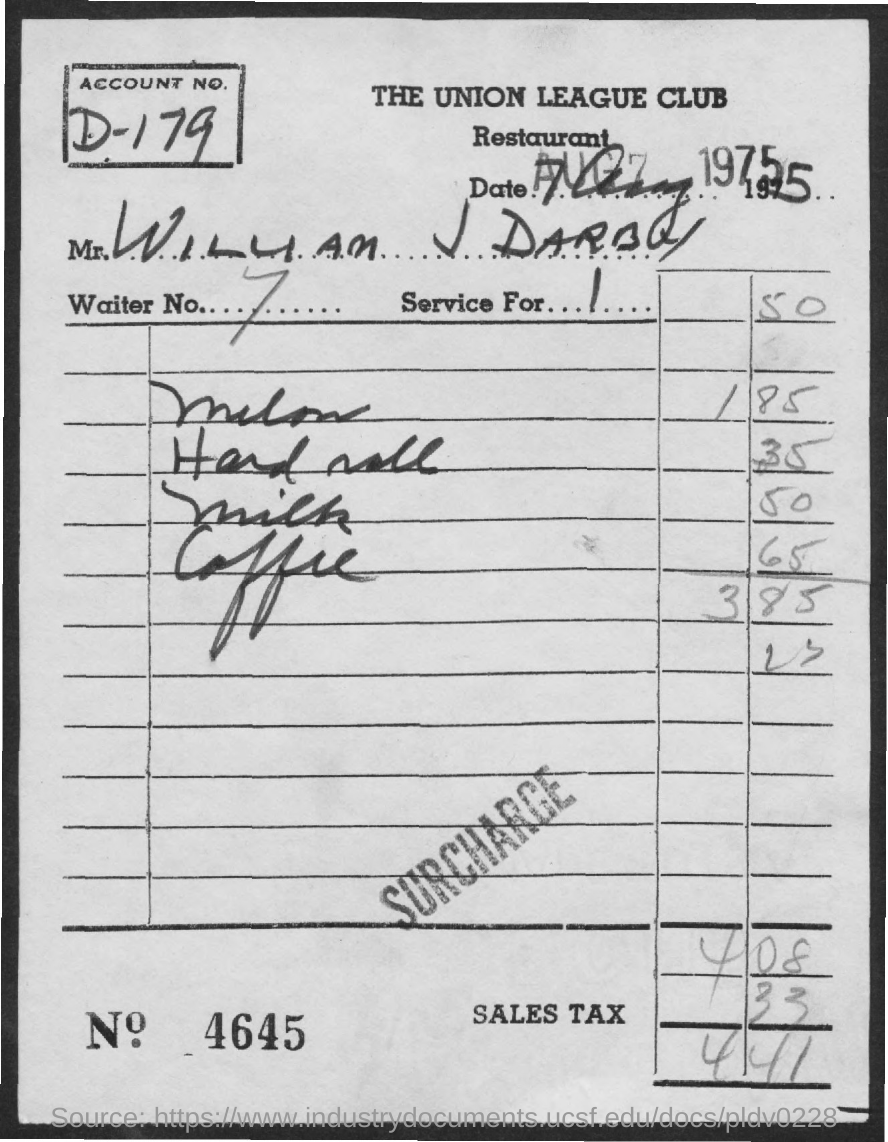Draw attention to some important aspects in this diagram. What is Bill Number 4645? The account number is D-179. The total amount is 441. The amount of sales tax is 33. 